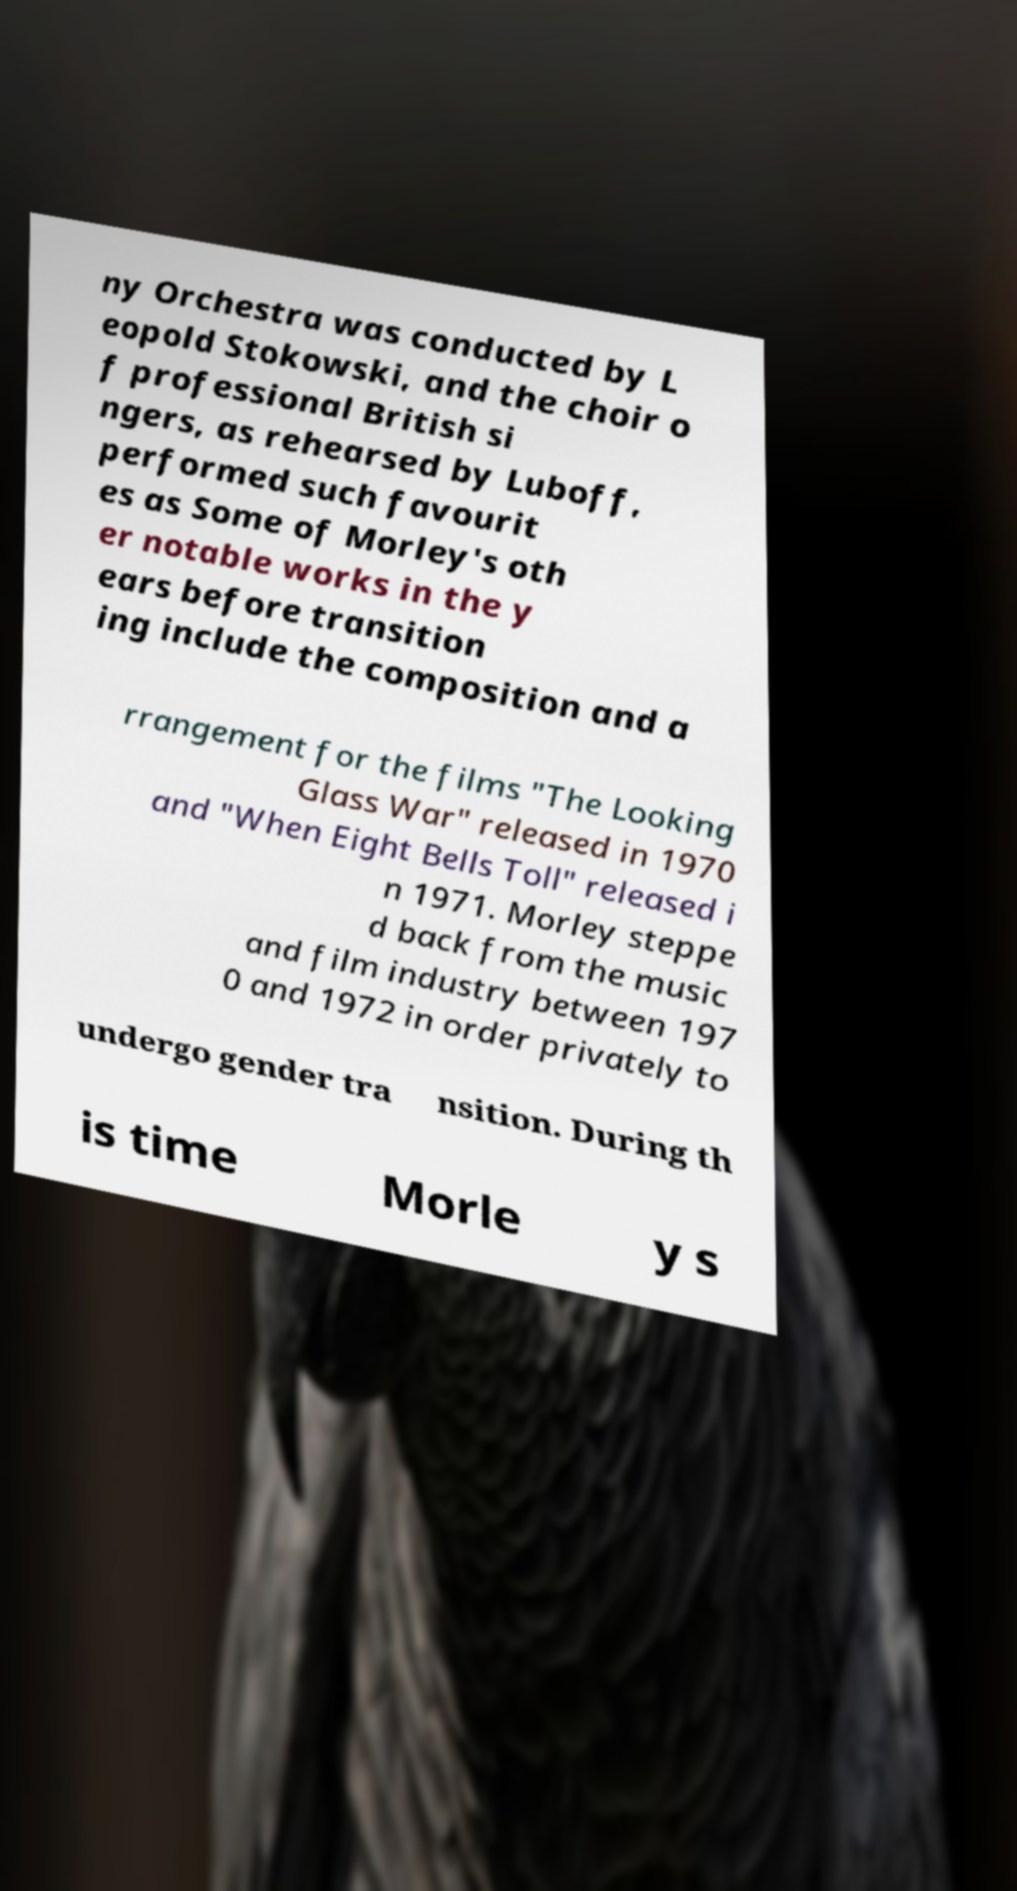Could you extract and type out the text from this image? ny Orchestra was conducted by L eopold Stokowski, and the choir o f professional British si ngers, as rehearsed by Luboff, performed such favourit es as Some of Morley's oth er notable works in the y ears before transition ing include the composition and a rrangement for the films "The Looking Glass War" released in 1970 and "When Eight Bells Toll" released i n 1971. Morley steppe d back from the music and film industry between 197 0 and 1972 in order privately to undergo gender tra nsition. During th is time Morle y s 